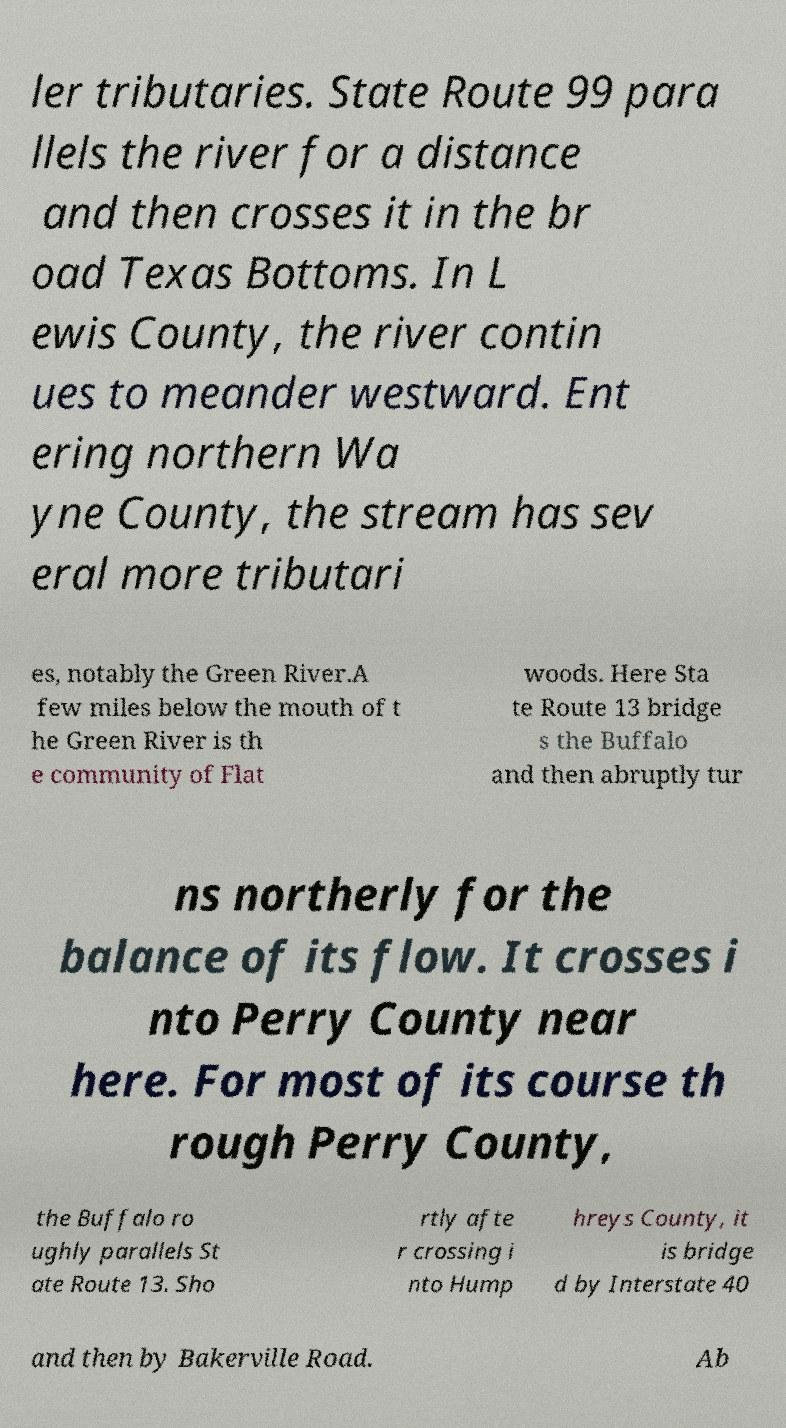I need the written content from this picture converted into text. Can you do that? ler tributaries. State Route 99 para llels the river for a distance and then crosses it in the br oad Texas Bottoms. In L ewis County, the river contin ues to meander westward. Ent ering northern Wa yne County, the stream has sev eral more tributari es, notably the Green River.A few miles below the mouth of t he Green River is th e community of Flat woods. Here Sta te Route 13 bridge s the Buffalo and then abruptly tur ns northerly for the balance of its flow. It crosses i nto Perry County near here. For most of its course th rough Perry County, the Buffalo ro ughly parallels St ate Route 13. Sho rtly afte r crossing i nto Hump hreys County, it is bridge d by Interstate 40 and then by Bakerville Road. Ab 